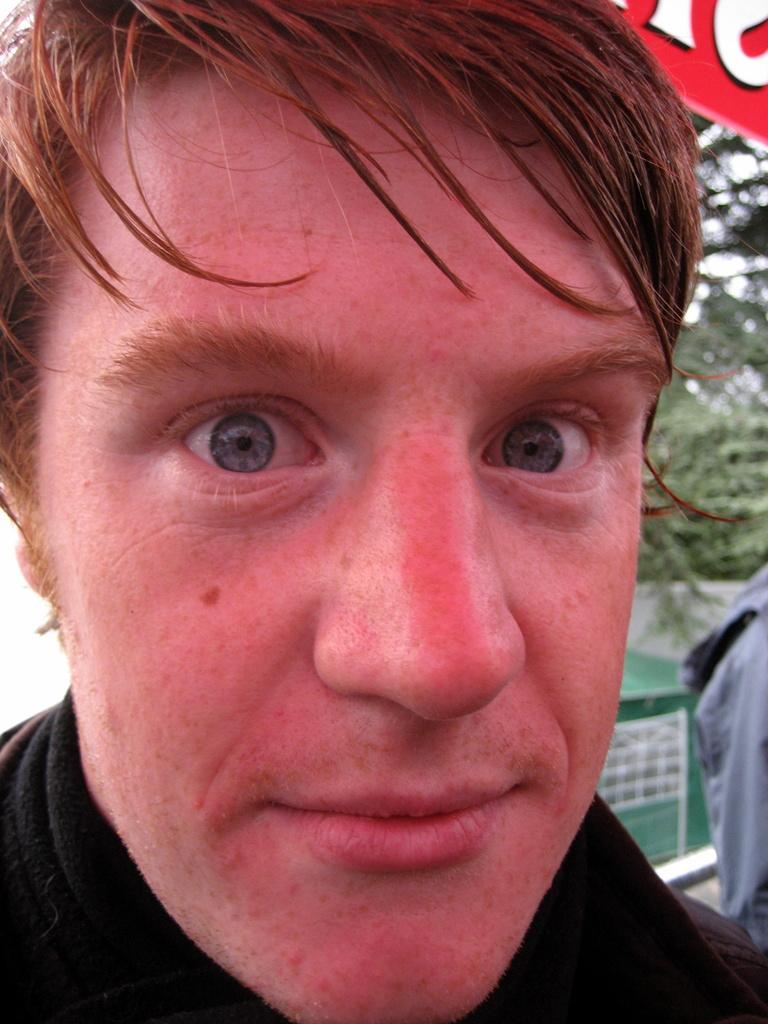What is the main subject of the image? There is a person's face in the image. Can you describe anything else visible in the image? There is a person in the background of the image. What can be seen in the background of the image? There are trees in the background of the image. Is the person wearing a veil in the image? There is no mention of a veil in the image, so it cannot be determined whether the person is wearing one or not. 